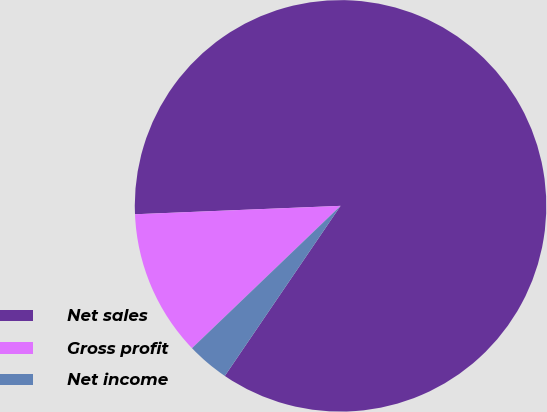Convert chart to OTSL. <chart><loc_0><loc_0><loc_500><loc_500><pie_chart><fcel>Net sales<fcel>Gross profit<fcel>Net income<nl><fcel>85.16%<fcel>11.51%<fcel>3.33%<nl></chart> 